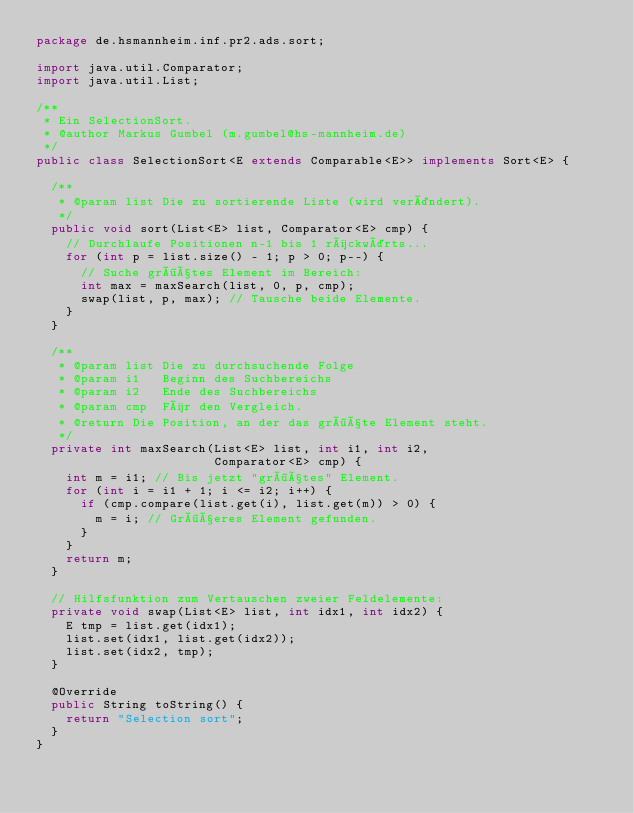Convert code to text. <code><loc_0><loc_0><loc_500><loc_500><_Java_>package de.hsmannheim.inf.pr2.ads.sort;

import java.util.Comparator;
import java.util.List;

/**
 * Ein SelectionSort.
 * @author Markus Gumbel (m.gumbel@hs-mannheim.de)
 */
public class SelectionSort<E extends Comparable<E>> implements Sort<E> {

  /**
   * @param list Die zu sortierende Liste (wird verändert).
   */
  public void sort(List<E> list, Comparator<E> cmp) {
    // Durchlaufe Positionen n-1 bis 1 rückwärts...
    for (int p = list.size() - 1; p > 0; p--) {
      // Suche größtes Element im Bereich:
      int max = maxSearch(list, 0, p, cmp);
      swap(list, p, max); // Tausche beide Elemente.
    }
  }

  /**
   * @param list Die zu durchsuchende Folge
   * @param i1   Beginn des Suchbereichs
   * @param i2   Ende des Suchbereichs
   * @param cmp  Für den Vergleich.
   * @return Die Position, an der das größte Element steht.
   */
  private int maxSearch(List<E> list, int i1, int i2,
                        Comparator<E> cmp) {
    int m = i1; // Bis jetzt "größtes" Element.
    for (int i = i1 + 1; i <= i2; i++) {
      if (cmp.compare(list.get(i), list.get(m)) > 0) {
        m = i; // Größeres Element gefunden.
      }
    }
    return m;
  }

  // Hilfsfunktion zum Vertauschen zweier Feldelemente:
  private void swap(List<E> list, int idx1, int idx2) {
    E tmp = list.get(idx1);
    list.set(idx1, list.get(idx2));
    list.set(idx2, tmp);
  }

  @Override
  public String toString() {
    return "Selection sort";
  }
}
</code> 